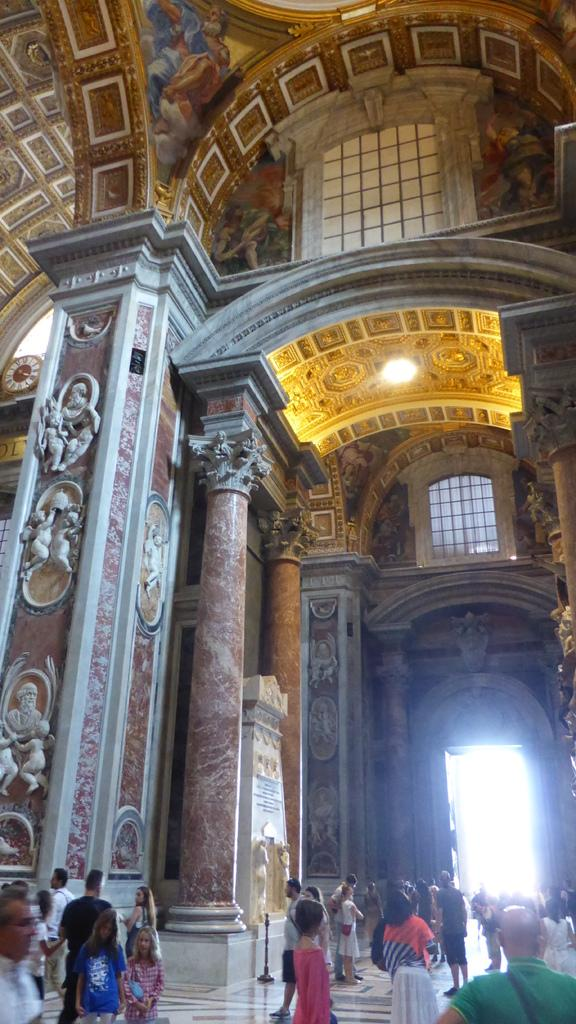Where was the image taken? The image was taken in a hall. What can be seen at the bottom of the image? There are people and a door at the bottom of the image. What is present at the top of the image? There is a light and windows at the top of the image. How many feet are visible in the image? There is no mention of feet in the image, so it is not possible to determine how many are visible. 